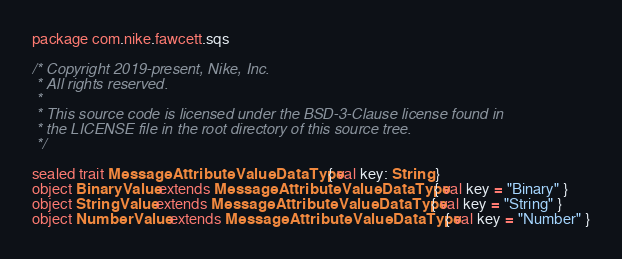Convert code to text. <code><loc_0><loc_0><loc_500><loc_500><_Scala_>package com.nike.fawcett.sqs

/* Copyright 2019-present, Nike, Inc.
 * All rights reserved.
 *
 * This source code is licensed under the BSD-3-Clause license found in
 * the LICENSE file in the root directory of this source tree.
 */

sealed trait MessageAttributeValueDataType { val key: String }
object BinaryValue extends MessageAttributeValueDataType { val key = "Binary" }
object StringValue extends MessageAttributeValueDataType { val key = "String" }
object NumberValue extends MessageAttributeValueDataType { val key = "Number" }

</code> 